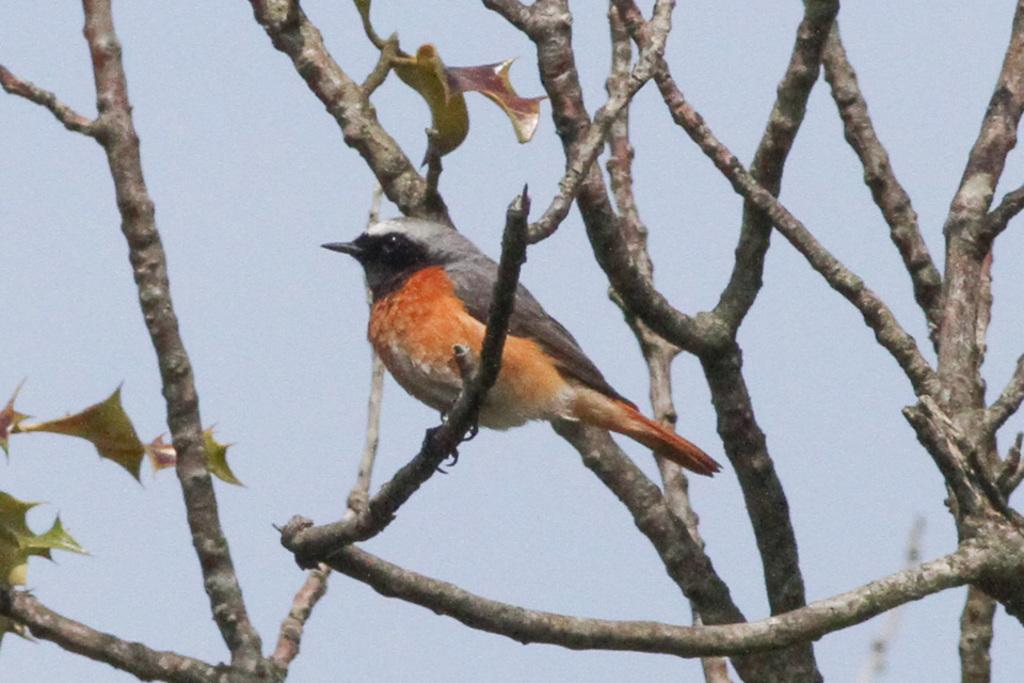What type of animal can be seen in the image? There is a bird in the image. Where is the bird located? The bird is on a tree branch. What type of cloud can be seen in the image? There is no cloud present in the image; it only features a bird on a tree branch. What role does the father play in the image? There is no reference to a father or any human figures in the image, so it's not possible to determine any role they might play. 